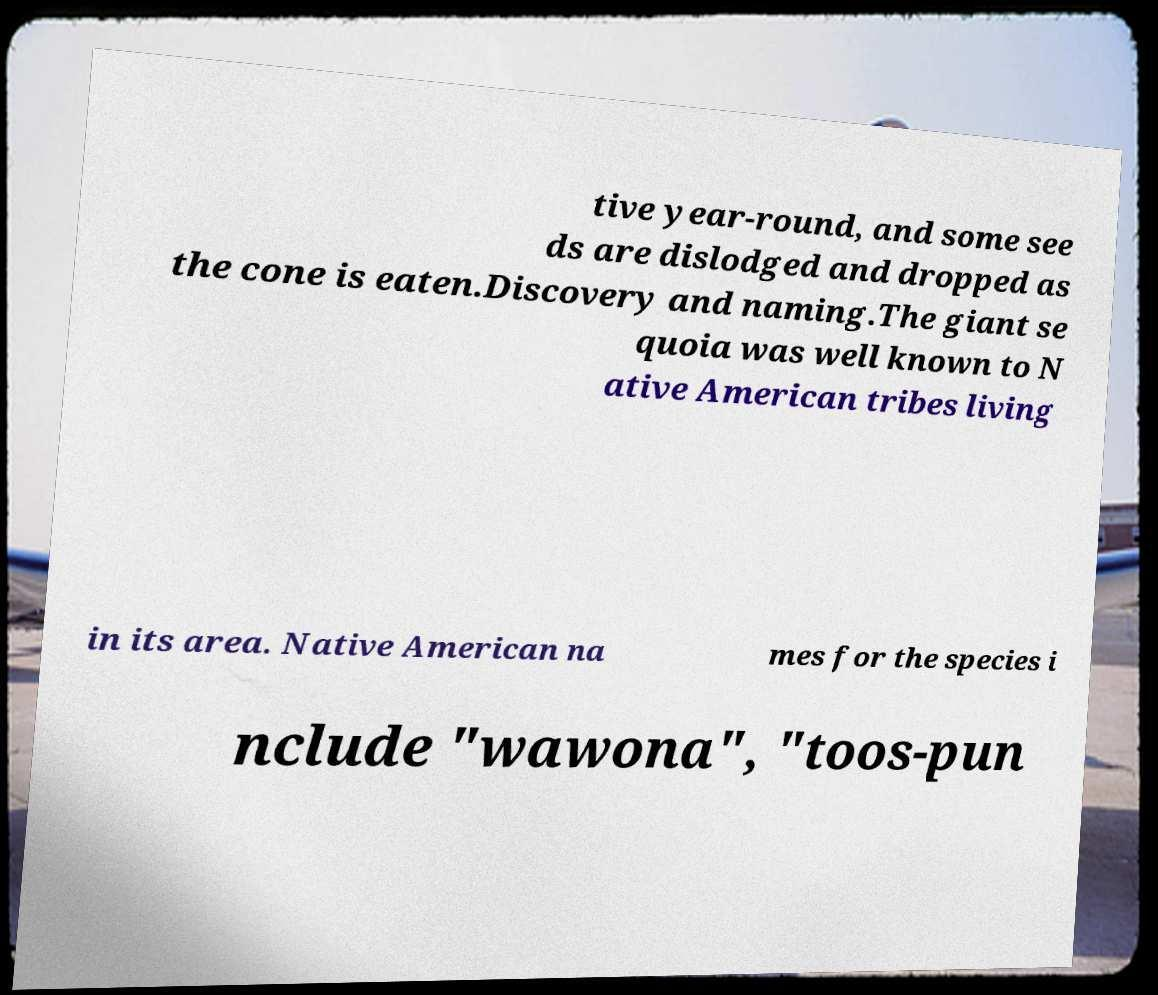Could you extract and type out the text from this image? tive year-round, and some see ds are dislodged and dropped as the cone is eaten.Discovery and naming.The giant se quoia was well known to N ative American tribes living in its area. Native American na mes for the species i nclude "wawona", "toos-pun 